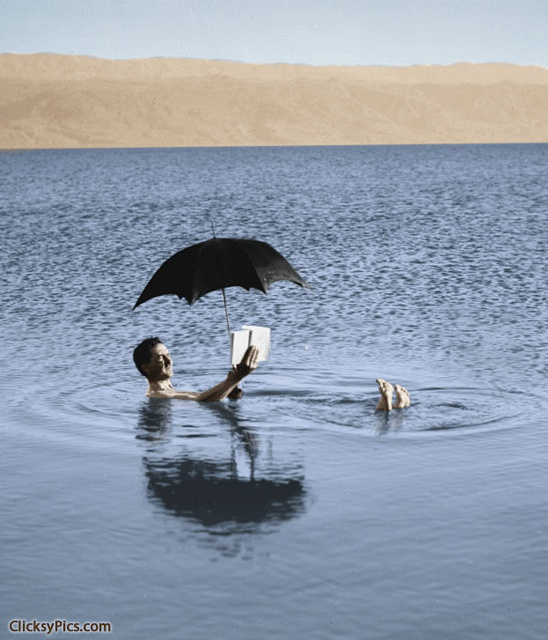Describe the objects in this image and their specific colors. I can see umbrella in lightblue, black, gray, and darkgray tones, people in lightblue, black, gray, lightgray, and darkgray tones, and book in lightblue, white, darkgray, and gray tones in this image. 